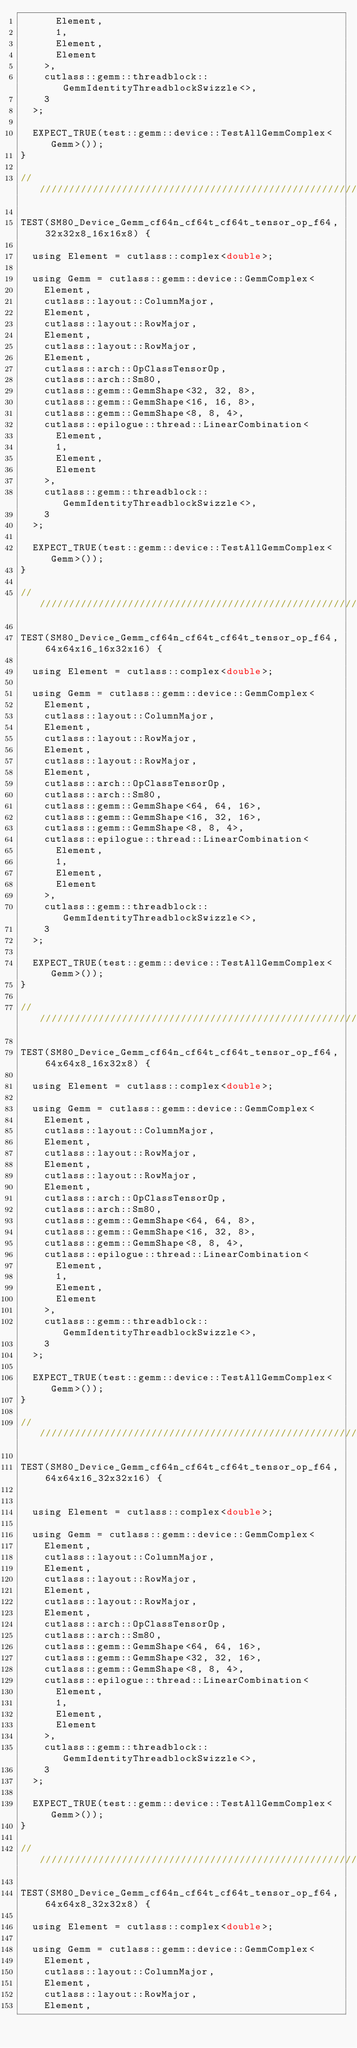<code> <loc_0><loc_0><loc_500><loc_500><_Cuda_>      Element,
      1,
      Element,
      Element
    >,
    cutlass::gemm::threadblock::GemmIdentityThreadblockSwizzle<>,
    3
  >;

  EXPECT_TRUE(test::gemm::device::TestAllGemmComplex<Gemm>());
}

/////////////////////////////////////////////////////////////////////////////////////////////////

TEST(SM80_Device_Gemm_cf64n_cf64t_cf64t_tensor_op_f64, 32x32x8_16x16x8) {
  
  using Element = cutlass::complex<double>;

  using Gemm = cutlass::gemm::device::GemmComplex<
    Element,
    cutlass::layout::ColumnMajor,
    Element,
    cutlass::layout::RowMajor,
    Element,
    cutlass::layout::RowMajor,
    Element,
    cutlass::arch::OpClassTensorOp,
    cutlass::arch::Sm80,
    cutlass::gemm::GemmShape<32, 32, 8>,
    cutlass::gemm::GemmShape<16, 16, 8>,
    cutlass::gemm::GemmShape<8, 8, 4>,
    cutlass::epilogue::thread::LinearCombination<
      Element,
      1,
      Element,
      Element
    >,
    cutlass::gemm::threadblock::GemmIdentityThreadblockSwizzle<>,
    3
  >;

  EXPECT_TRUE(test::gemm::device::TestAllGemmComplex<Gemm>());
}

/////////////////////////////////////////////////////////////////////////////////////////////////

TEST(SM80_Device_Gemm_cf64n_cf64t_cf64t_tensor_op_f64, 64x64x16_16x32x16) {
  
  using Element = cutlass::complex<double>;

  using Gemm = cutlass::gemm::device::GemmComplex<
    Element,
    cutlass::layout::ColumnMajor,
    Element,
    cutlass::layout::RowMajor,
    Element,
    cutlass::layout::RowMajor,
    Element,
    cutlass::arch::OpClassTensorOp,
    cutlass::arch::Sm80,
    cutlass::gemm::GemmShape<64, 64, 16>,
    cutlass::gemm::GemmShape<16, 32, 16>,
    cutlass::gemm::GemmShape<8, 8, 4>,
    cutlass::epilogue::thread::LinearCombination<
      Element,
      1,
      Element,
      Element
    >,
    cutlass::gemm::threadblock::GemmIdentityThreadblockSwizzle<>,
    3
  >;

  EXPECT_TRUE(test::gemm::device::TestAllGemmComplex<Gemm>());
}

/////////////////////////////////////////////////////////////////////////////////////////////////

TEST(SM80_Device_Gemm_cf64n_cf64t_cf64t_tensor_op_f64, 64x64x8_16x32x8) {
  
  using Element = cutlass::complex<double>;

  using Gemm = cutlass::gemm::device::GemmComplex<
    Element,
    cutlass::layout::ColumnMajor,
    Element,
    cutlass::layout::RowMajor,
    Element,
    cutlass::layout::RowMajor,
    Element,
    cutlass::arch::OpClassTensorOp,
    cutlass::arch::Sm80,
    cutlass::gemm::GemmShape<64, 64, 8>,
    cutlass::gemm::GemmShape<16, 32, 8>,
    cutlass::gemm::GemmShape<8, 8, 4>,
    cutlass::epilogue::thread::LinearCombination<
      Element,
      1,
      Element,
      Element
    >,
    cutlass::gemm::threadblock::GemmIdentityThreadblockSwizzle<>,
    3
  >;

  EXPECT_TRUE(test::gemm::device::TestAllGemmComplex<Gemm>());
}

/////////////////////////////////////////////////////////////////////////////////////////////////

TEST(SM80_Device_Gemm_cf64n_cf64t_cf64t_tensor_op_f64, 64x64x16_32x32x16) {

  
  using Element = cutlass::complex<double>;

  using Gemm = cutlass::gemm::device::GemmComplex<
    Element,
    cutlass::layout::ColumnMajor,
    Element,
    cutlass::layout::RowMajor,
    Element,
    cutlass::layout::RowMajor,
    Element,
    cutlass::arch::OpClassTensorOp,
    cutlass::arch::Sm80,
    cutlass::gemm::GemmShape<64, 64, 16>,
    cutlass::gemm::GemmShape<32, 32, 16>,
    cutlass::gemm::GemmShape<8, 8, 4>,
    cutlass::epilogue::thread::LinearCombination<
      Element,
      1,
      Element,
      Element
    >,
    cutlass::gemm::threadblock::GemmIdentityThreadblockSwizzle<>,
    3
  >;

  EXPECT_TRUE(test::gemm::device::TestAllGemmComplex<Gemm>());
}

/////////////////////////////////////////////////////////////////////////////////////////////////

TEST(SM80_Device_Gemm_cf64n_cf64t_cf64t_tensor_op_f64, 64x64x8_32x32x8) {
  
  using Element = cutlass::complex<double>;

  using Gemm = cutlass::gemm::device::GemmComplex<
    Element,
    cutlass::layout::ColumnMajor,
    Element,
    cutlass::layout::RowMajor,
    Element,</code> 